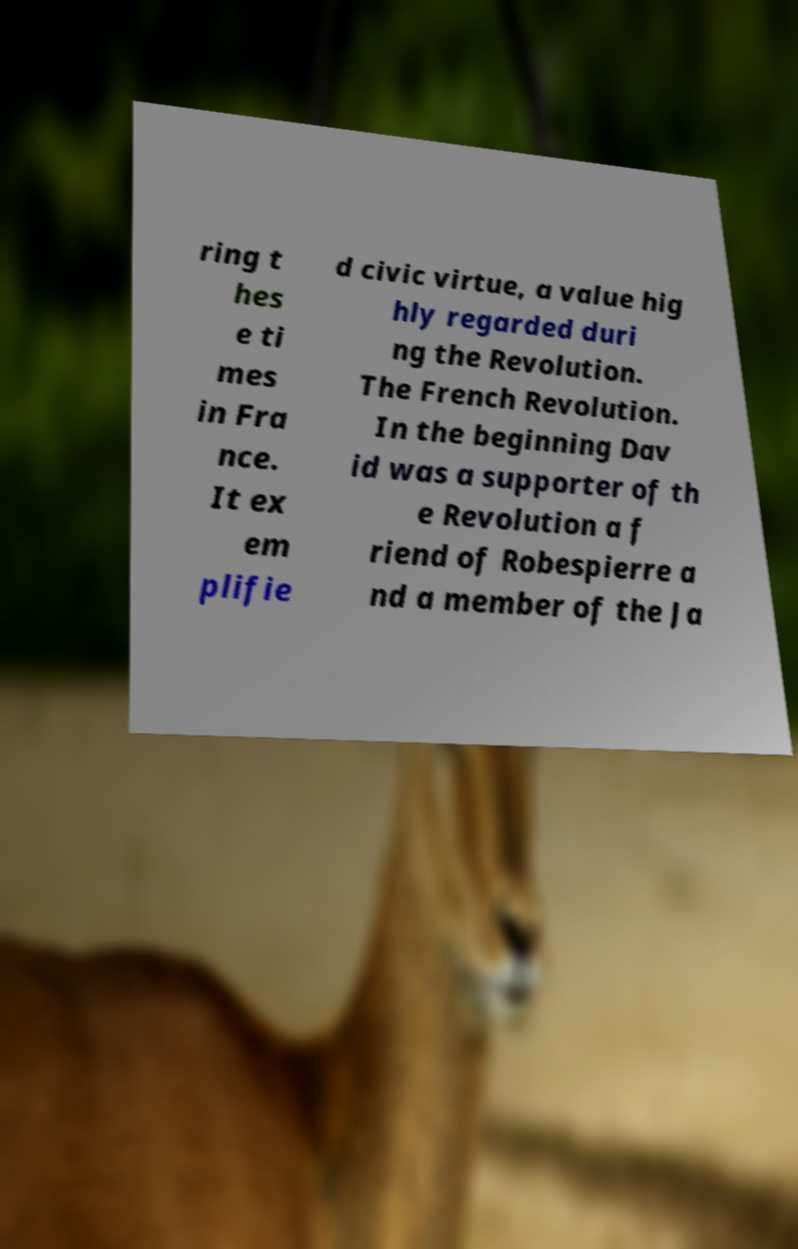Could you assist in decoding the text presented in this image and type it out clearly? ring t hes e ti mes in Fra nce. It ex em plifie d civic virtue, a value hig hly regarded duri ng the Revolution. The French Revolution. In the beginning Dav id was a supporter of th e Revolution a f riend of Robespierre a nd a member of the Ja 